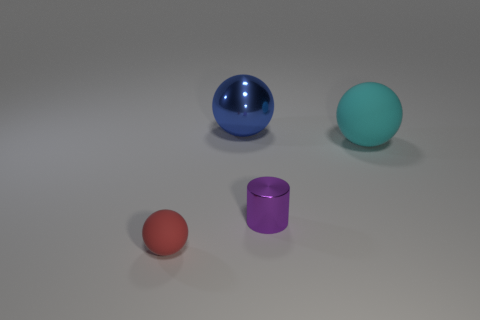Is the material of the large blue thing the same as the sphere in front of the cyan rubber sphere?
Provide a short and direct response. No. Does the big cyan thing have the same shape as the red object?
Keep it short and to the point. Yes. There is a big cyan object that is the same shape as the red rubber thing; what material is it?
Your response must be concise. Rubber. What color is the sphere that is behind the purple object and left of the big matte thing?
Make the answer very short. Blue. What color is the tiny metal cylinder?
Keep it short and to the point. Purple. Is there another red object of the same shape as the red matte object?
Your answer should be compact. No. There is a object behind the cyan thing; what is its size?
Offer a very short reply. Large. There is a object that is the same size as the cyan matte sphere; what material is it?
Provide a succinct answer. Metal. Is the number of large matte things greater than the number of rubber spheres?
Your answer should be compact. No. What is the size of the rubber sphere behind the object in front of the purple object?
Offer a very short reply. Large. 